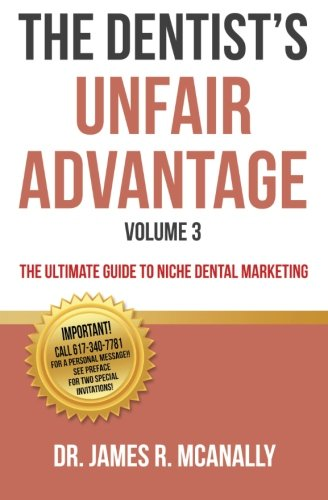What is the genre of this book? This book falls within the genre of Dental Marketing and Professional Development, providing targeted strategies for dentists. 